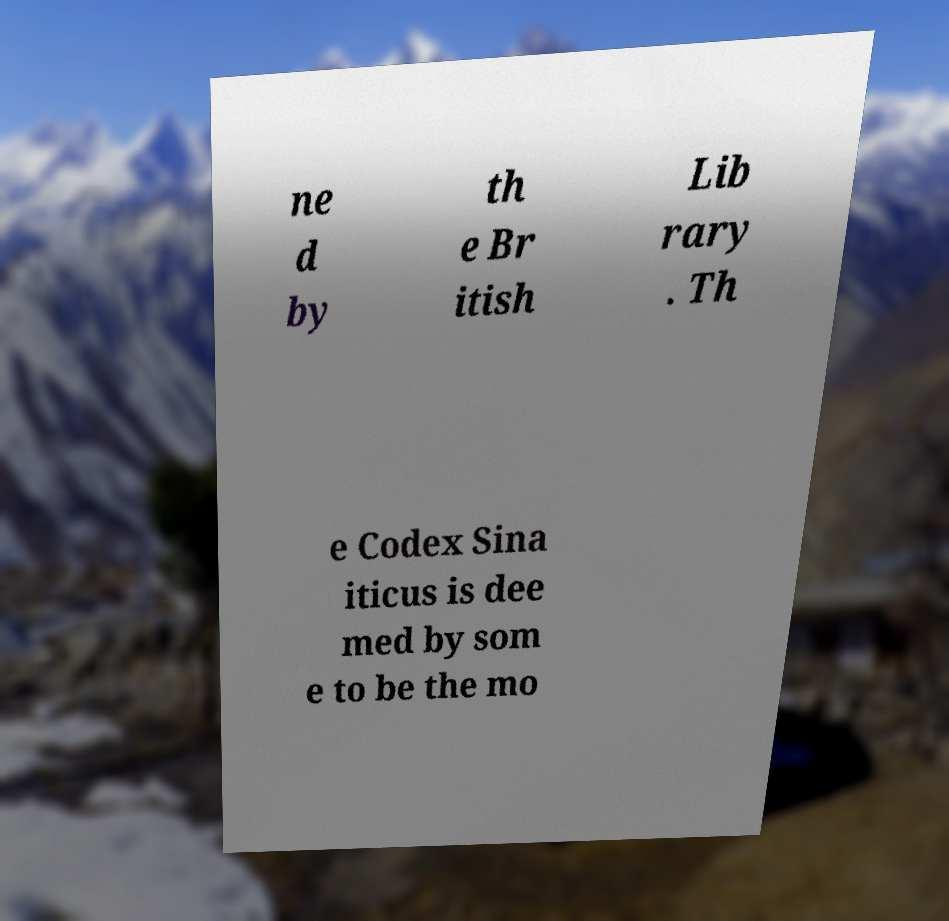Can you read and provide the text displayed in the image?This photo seems to have some interesting text. Can you extract and type it out for me? ne d by th e Br itish Lib rary . Th e Codex Sina iticus is dee med by som e to be the mo 